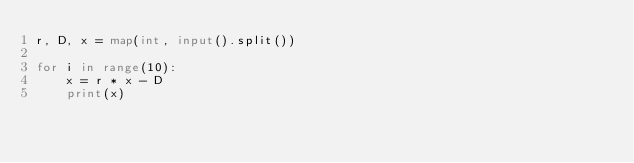Convert code to text. <code><loc_0><loc_0><loc_500><loc_500><_Python_>r, D, x = map(int, input().split())

for i in range(10):
    x = r * x - D
    print(x)</code> 